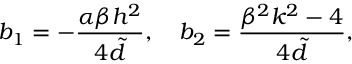Convert formula to latex. <formula><loc_0><loc_0><loc_500><loc_500>b _ { 1 } = - \frac { \alpha \beta h ^ { 2 } } { 4 { \tilde { d } } } , b _ { 2 } = \frac { \beta ^ { 2 } k ^ { 2 } - 4 } { 4 { \tilde { d } } } ,</formula> 